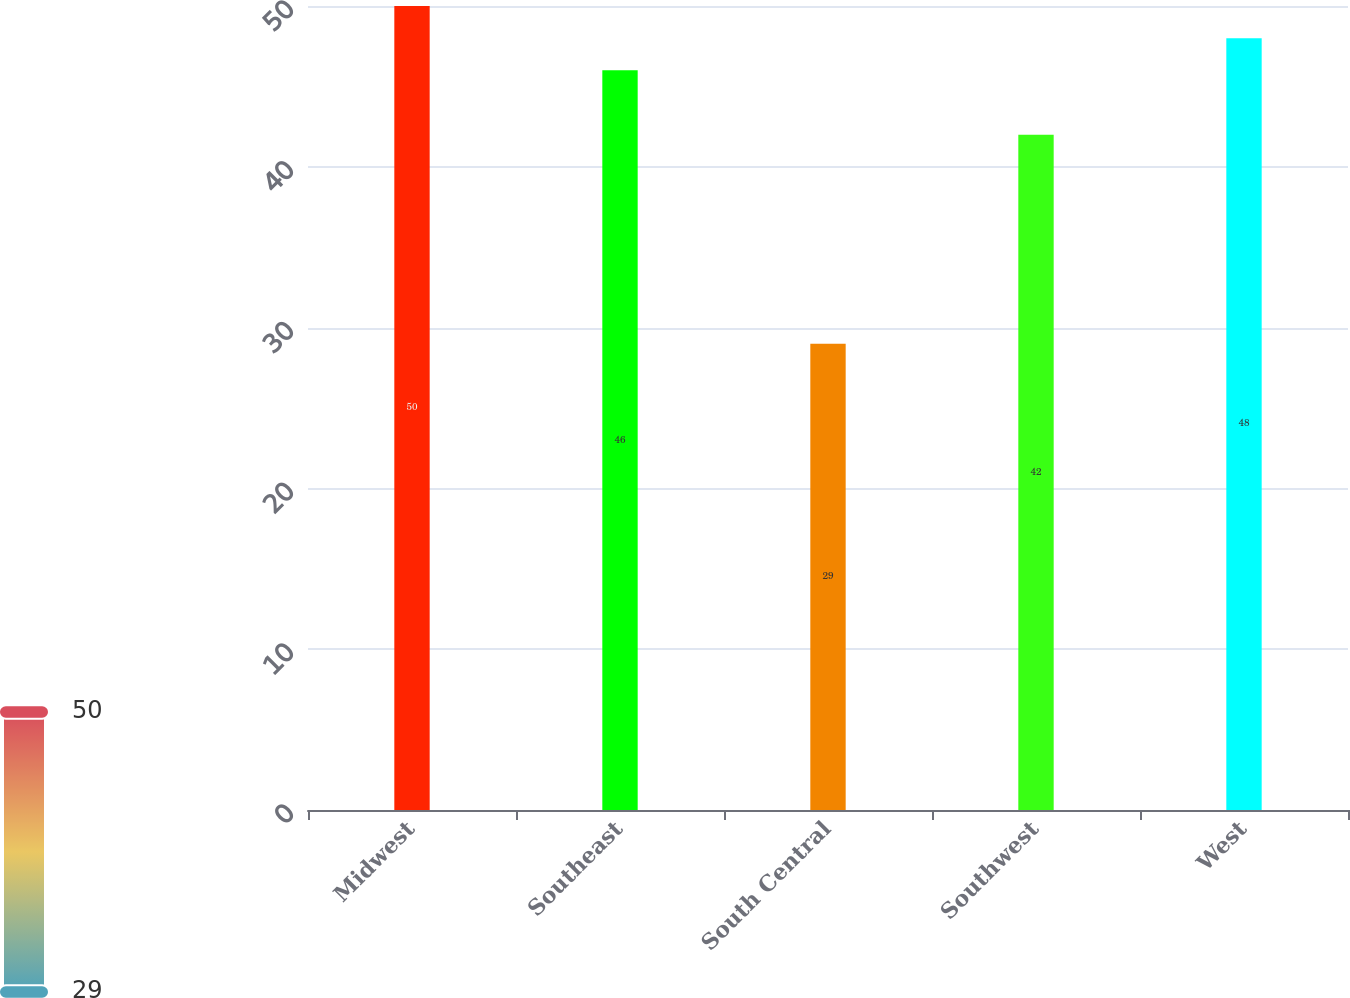Convert chart to OTSL. <chart><loc_0><loc_0><loc_500><loc_500><bar_chart><fcel>Midwest<fcel>Southeast<fcel>South Central<fcel>Southwest<fcel>West<nl><fcel>50<fcel>46<fcel>29<fcel>42<fcel>48<nl></chart> 